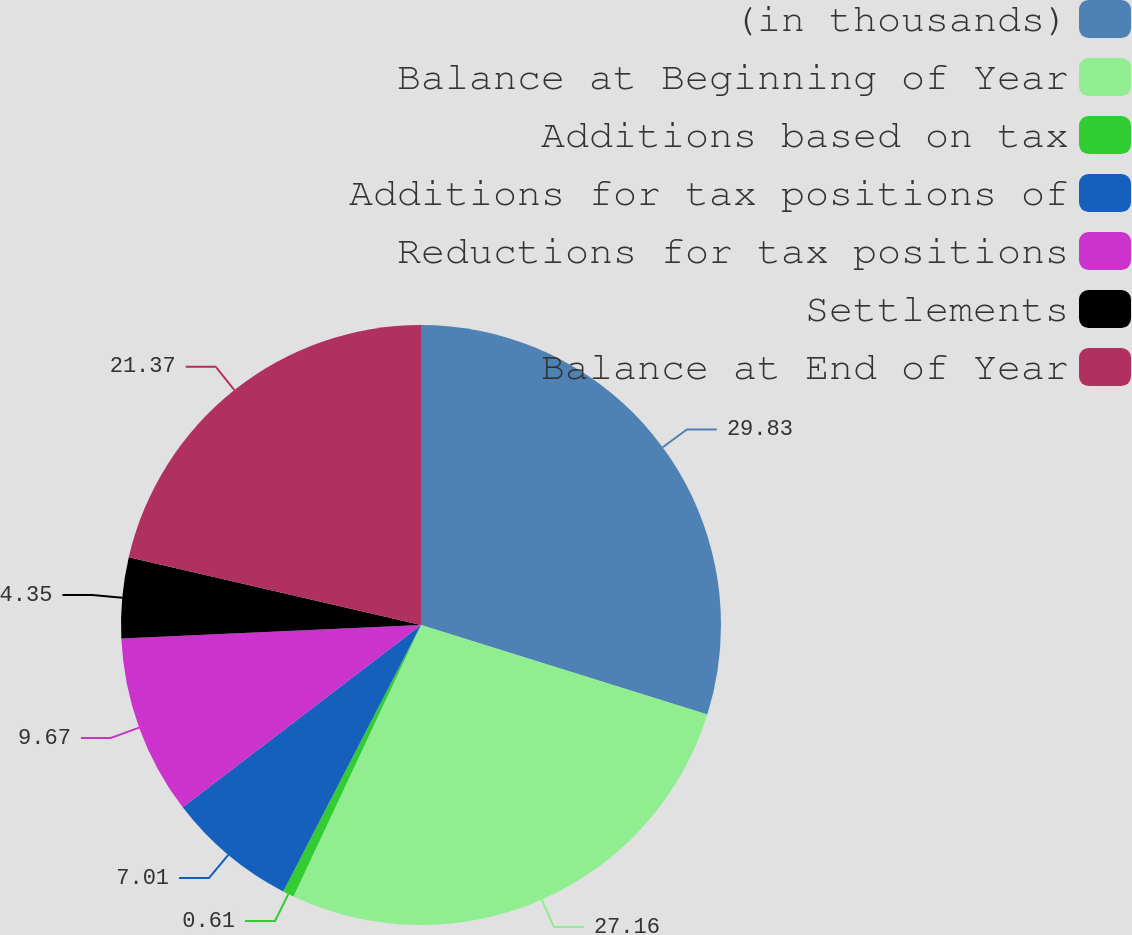Convert chart. <chart><loc_0><loc_0><loc_500><loc_500><pie_chart><fcel>(in thousands)<fcel>Balance at Beginning of Year<fcel>Additions based on tax<fcel>Additions for tax positions of<fcel>Reductions for tax positions<fcel>Settlements<fcel>Balance at End of Year<nl><fcel>29.82%<fcel>27.16%<fcel>0.61%<fcel>7.01%<fcel>9.67%<fcel>4.35%<fcel>21.37%<nl></chart> 